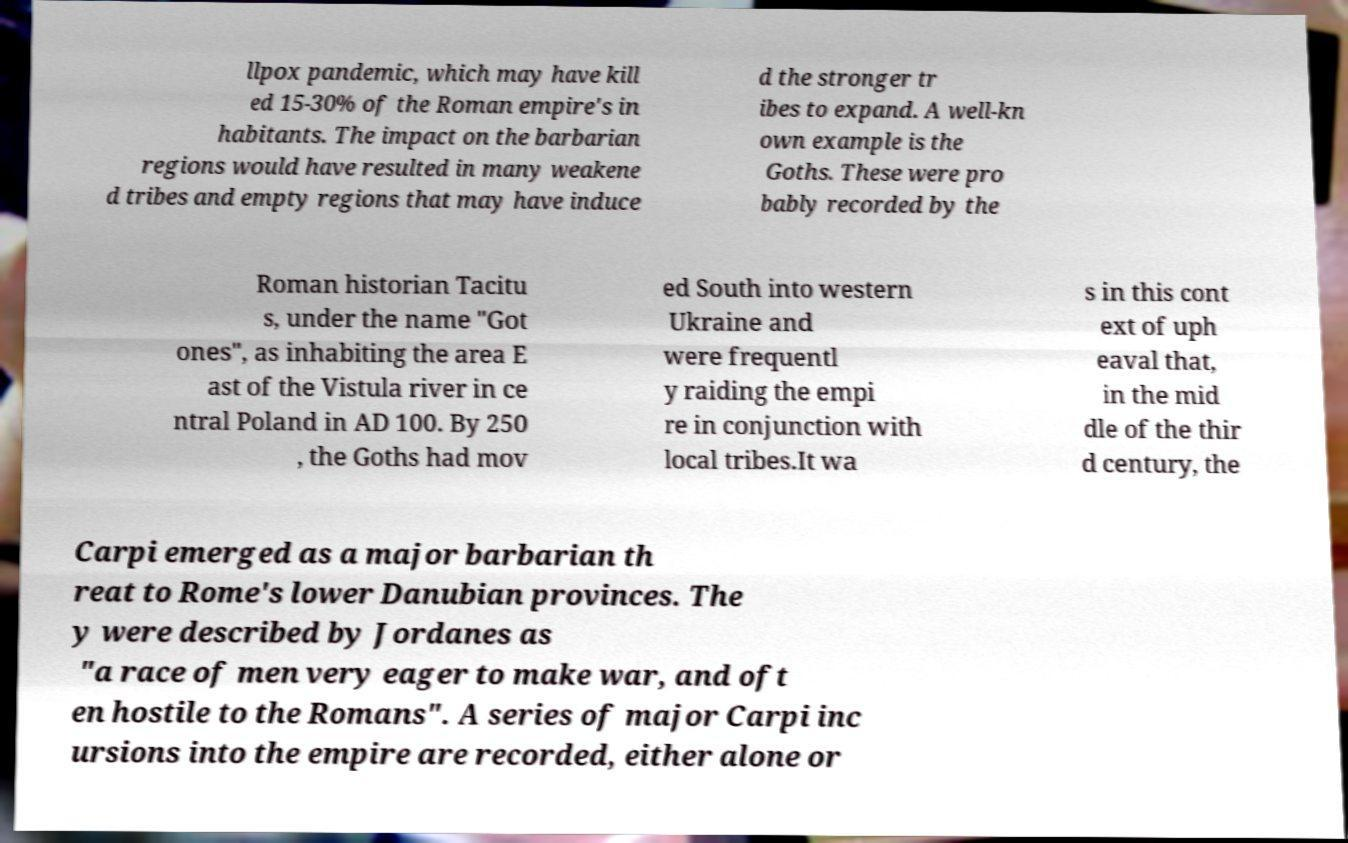Can you read and provide the text displayed in the image?This photo seems to have some interesting text. Can you extract and type it out for me? llpox pandemic, which may have kill ed 15-30% of the Roman empire's in habitants. The impact on the barbarian regions would have resulted in many weakene d tribes and empty regions that may have induce d the stronger tr ibes to expand. A well-kn own example is the Goths. These were pro bably recorded by the Roman historian Tacitu s, under the name "Got ones", as inhabiting the area E ast of the Vistula river in ce ntral Poland in AD 100. By 250 , the Goths had mov ed South into western Ukraine and were frequentl y raiding the empi re in conjunction with local tribes.It wa s in this cont ext of uph eaval that, in the mid dle of the thir d century, the Carpi emerged as a major barbarian th reat to Rome's lower Danubian provinces. The y were described by Jordanes as "a race of men very eager to make war, and oft en hostile to the Romans". A series of major Carpi inc ursions into the empire are recorded, either alone or 